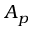<formula> <loc_0><loc_0><loc_500><loc_500>A _ { p }</formula> 